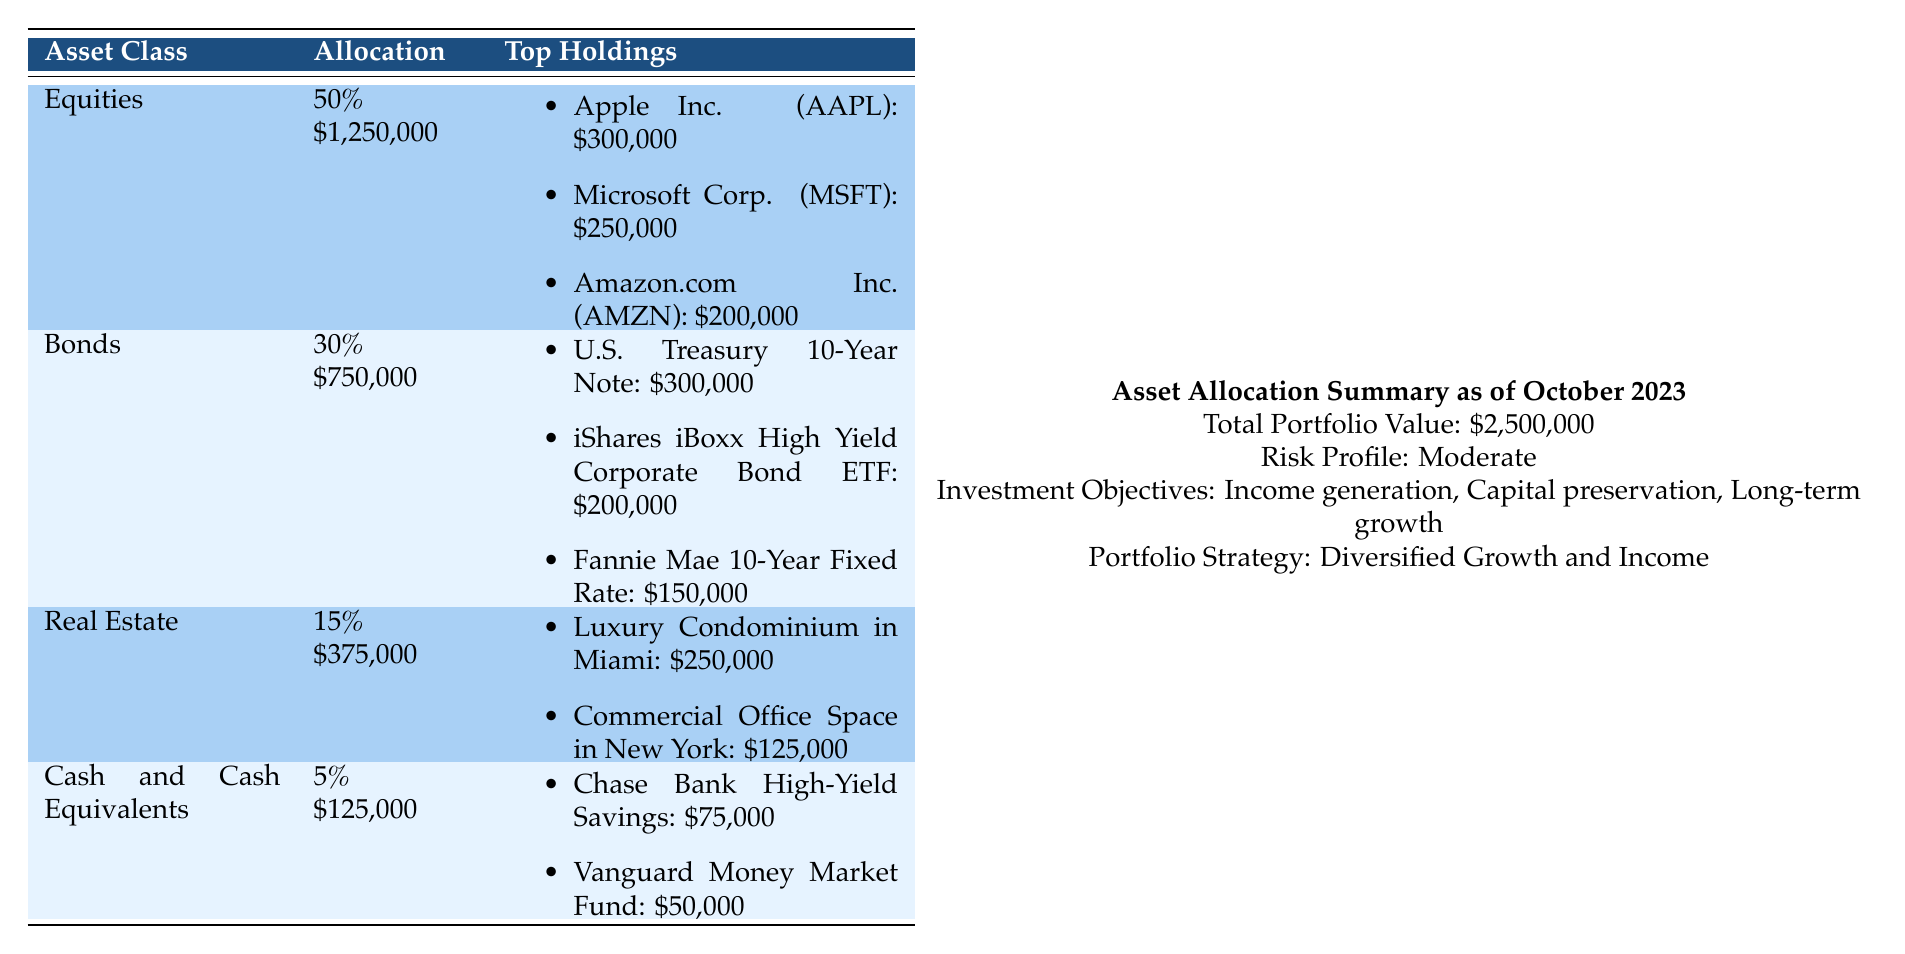What is the total value of the investment portfolio? The total value is directly stated as \$2,500,000 at the top of the table.
Answer: \$2,500,000 What percentage of the portfolio is allocated to bonds? The bonds allocation percentage is clearly listed as 30%.
Answer: 30% How much is invested in equities? The total value allocated to equities is given as \$1,250,000 in the table.
Answer: \$1,250,000 What is the value of the top holding in real estate? The top holding in real estate, the Luxury Condominium in Miami, is valued at \$250,000 according to the table.
Answer: \$250,000 Which asset class has the least allocation? Cash and Cash Equivalents occupy 5%, which is the lowest allocation percentage compared to others.
Answer: Cash and Cash Equivalents What are the total holdings of Apple Inc., Microsoft Corp., and Amazon.com Inc. combined? Adding their values: \$300,000 + \$250,000 + \$200,000 = \$750,000 gives the total for these three equities.
Answer: \$750,000 Is the risk profile of the portfolio high? The risk profile is classified as moderate, not high.
Answer: No Which bond has the highest value in the portfolio? U.S. Treasury 10-Year Note has the highest value at \$300,000 among the bonds listed.
Answer: U.S. Treasury 10-Year Note How much more is invested in equities compared to real estate? The difference is calculated as \$1,250,000 (equities) - \$375,000 (real estate) = \$875,000.
Answer: \$875,000 What is the combined value of cash holdings? The total cash holdings sum to \$75,000 (Chase Bank High-Yield Savings) + \$50,000 (Vanguard Money Market Fund) = \$125,000.
Answer: \$125,000 How does the bond allocation percentage compare to the real estate allocation? Bonds make up 30%, while real estate is at 15%; bonds have double the allocation of real estate.
Answer: Bonds > Real Estate What percentage of the portfolio is allocated to the top three equities? Their combined value is \$750,000, which is 30% of the total portfolio \$2,500,000, calculated as (\$750,000 / \$2,500,000) * 100.
Answer: 30% 